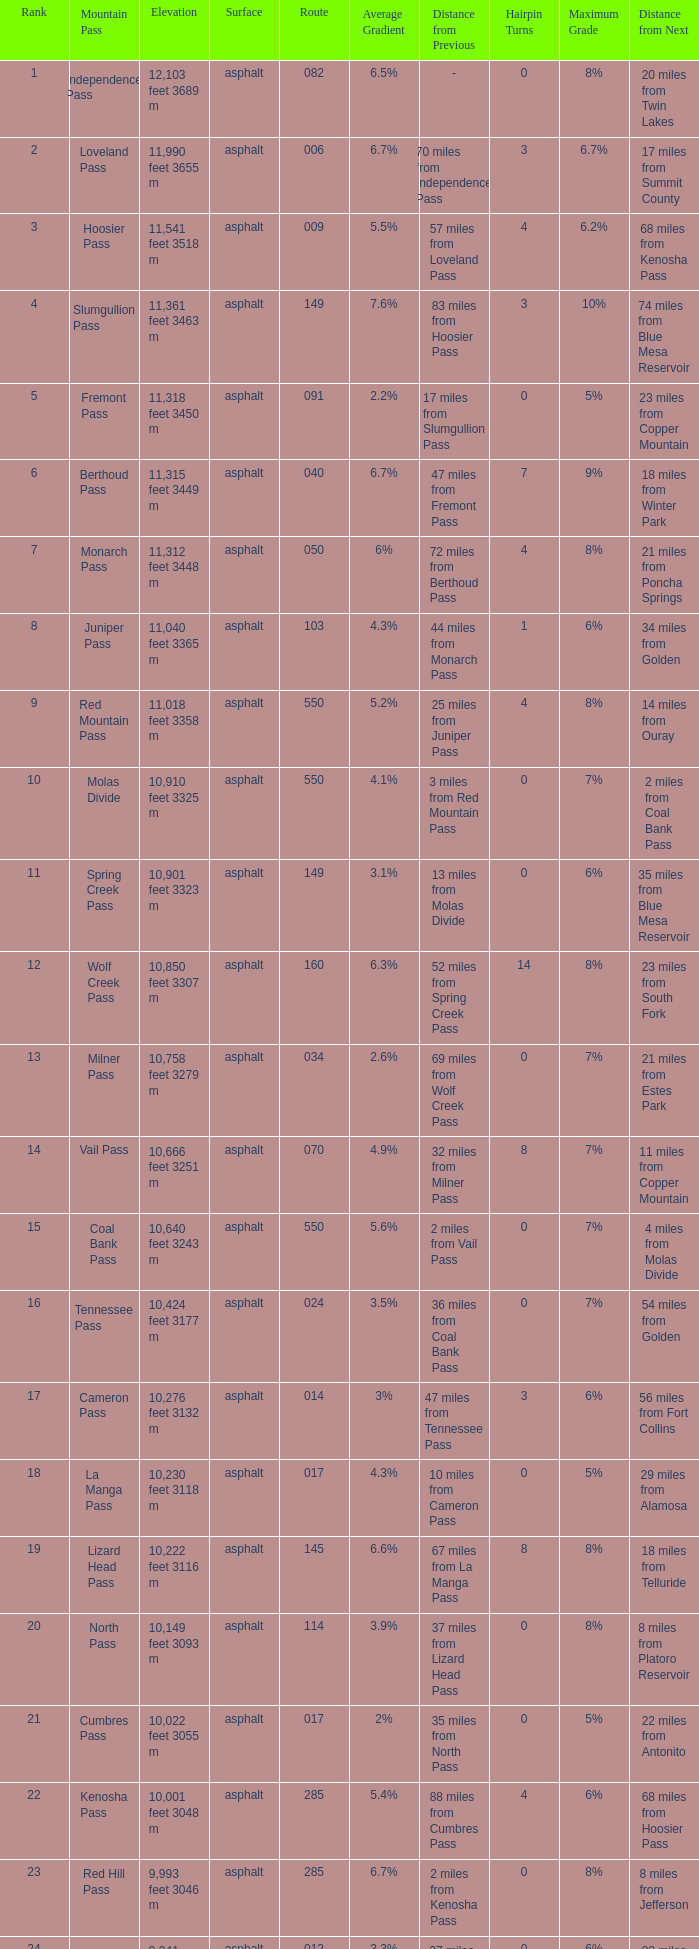What is the Surface of the Route less than 7? Asphalt. 